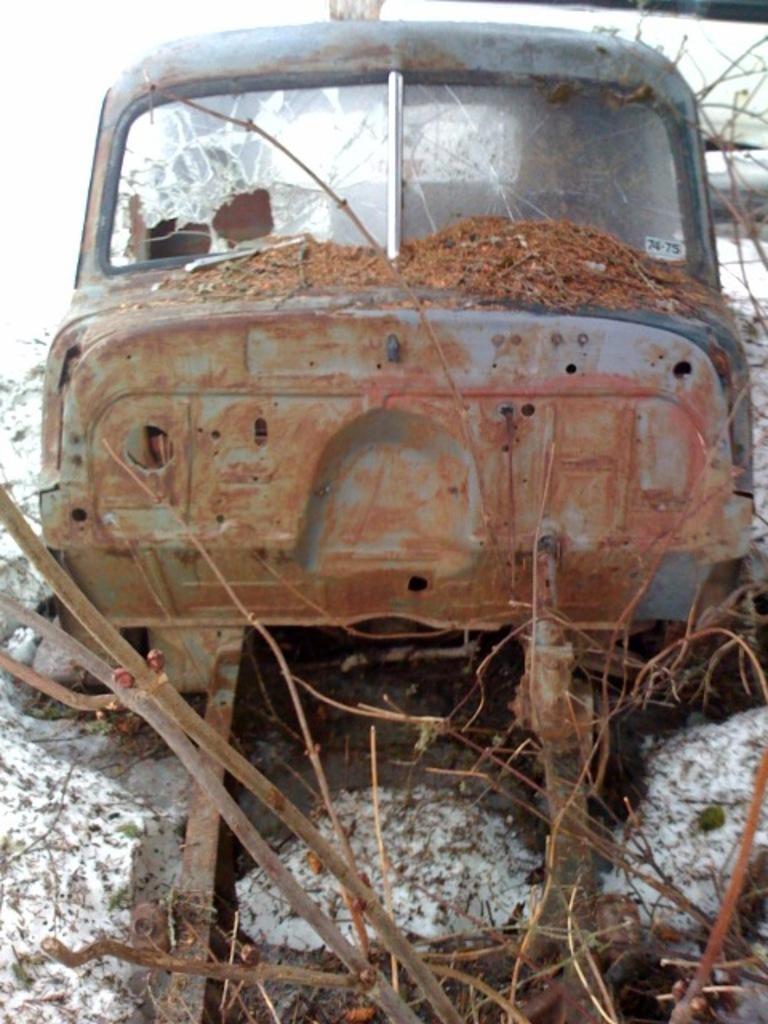In one or two sentences, can you explain what this image depicts? This looks like a damaged car. I can see the broken glasses. I think this is the scrap. I can see the branches. This looks like a slow. 